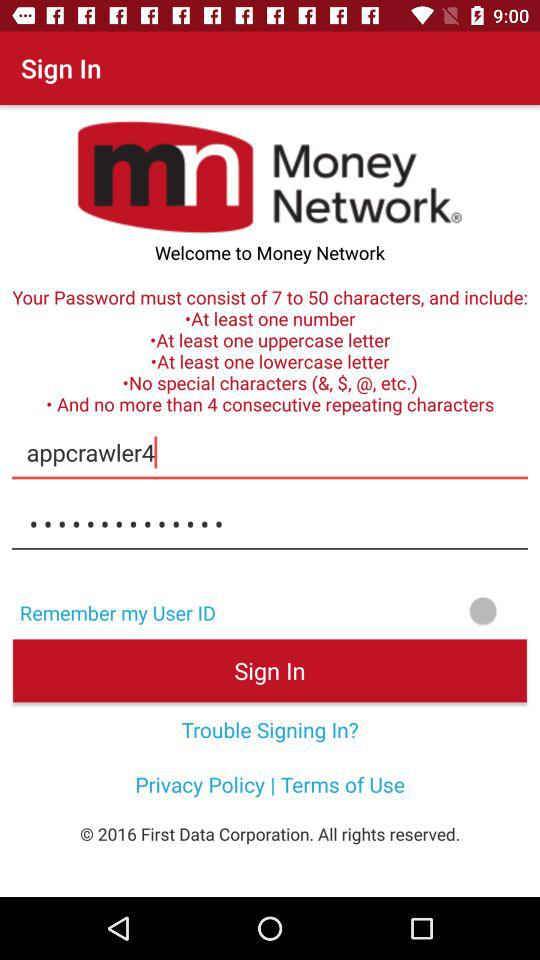What is the application name? The application name is "Money Network". 